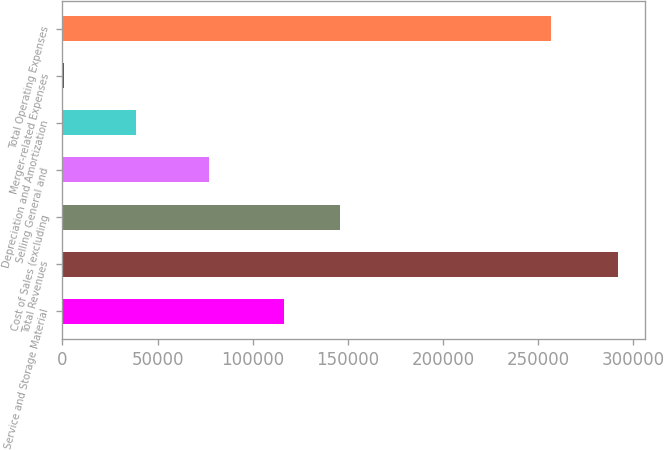Convert chart to OTSL. <chart><loc_0><loc_0><loc_500><loc_500><bar_chart><fcel>Service and Storage Material<fcel>Total Revenues<fcel>Cost of Sales (excluding<fcel>Selling General and<fcel>Depreciation and Amortization<fcel>Merger-related Expenses<fcel>Total Operating Expenses<nl><fcel>116661<fcel>291673<fcel>145723<fcel>76822<fcel>38921<fcel>1049<fcel>256710<nl></chart> 